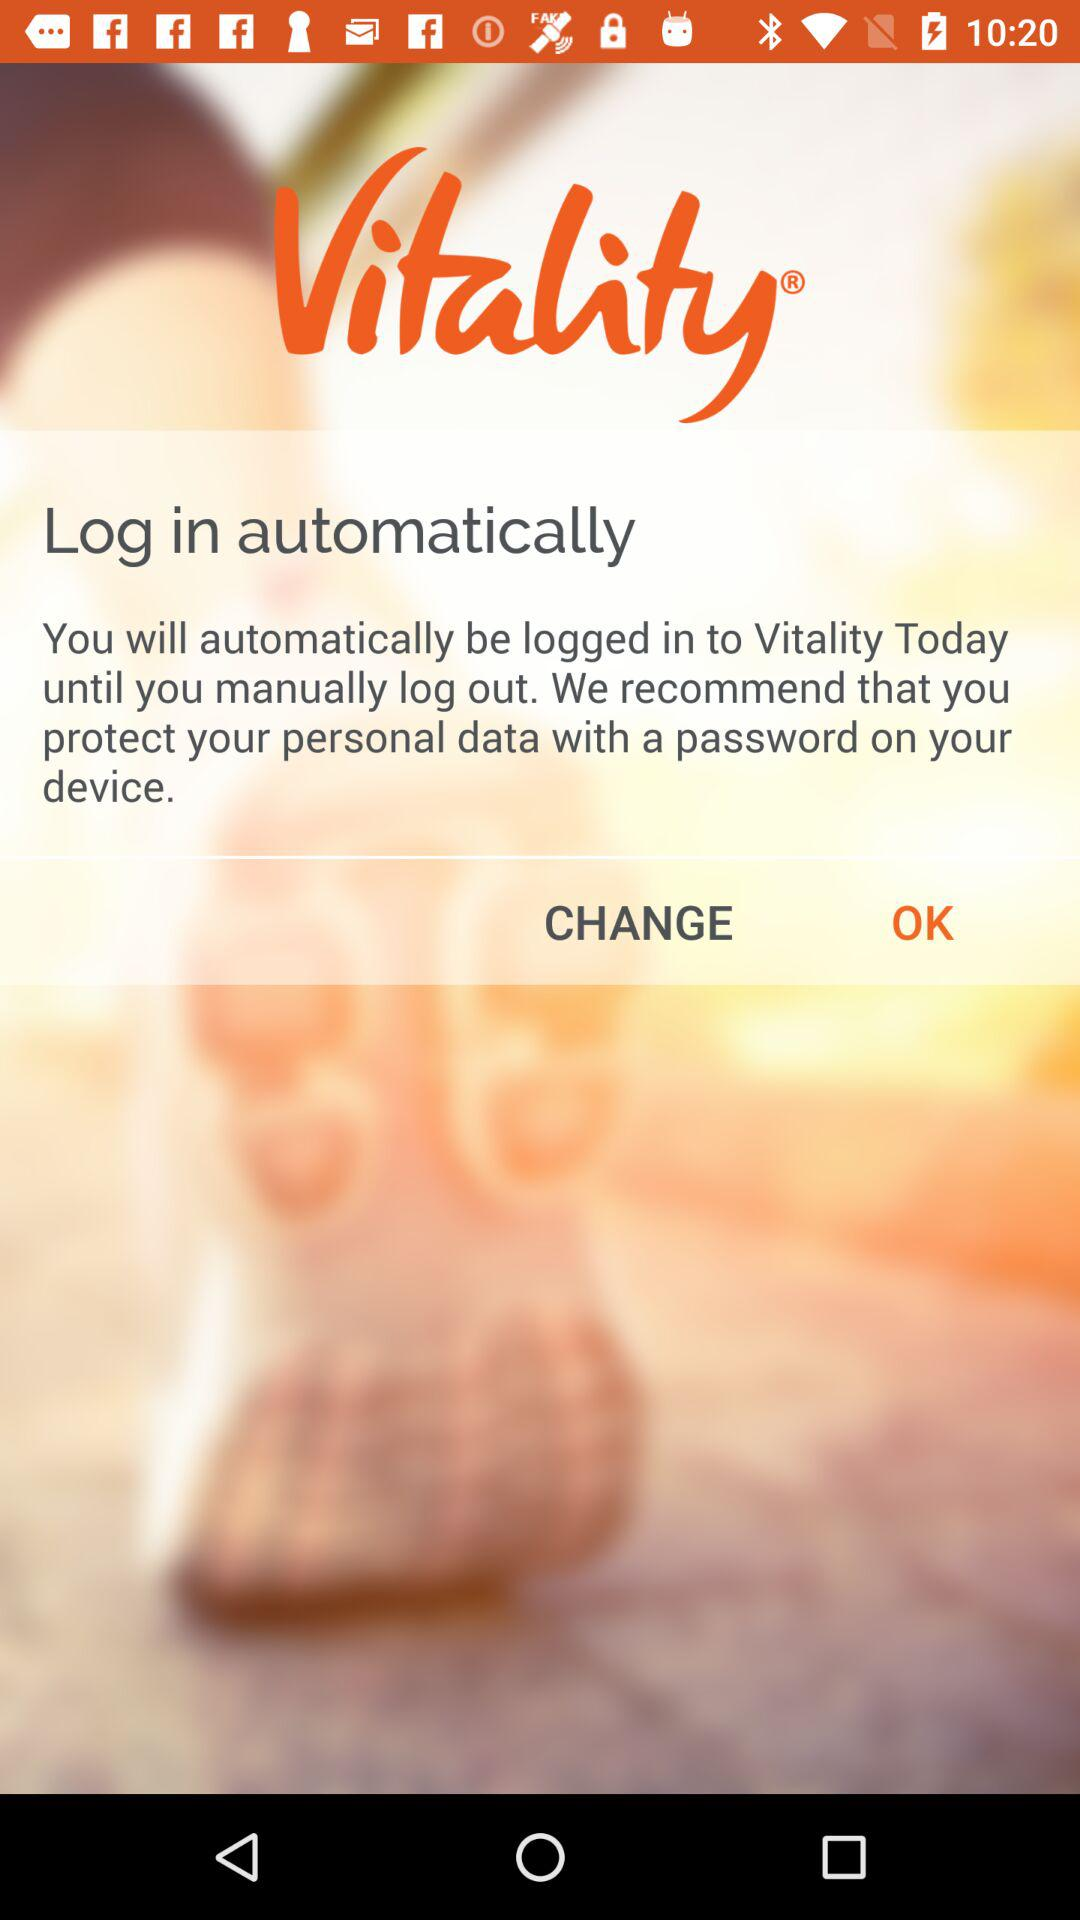What is the version of this application?
When the provided information is insufficient, respond with <no answer>. <no answer> 